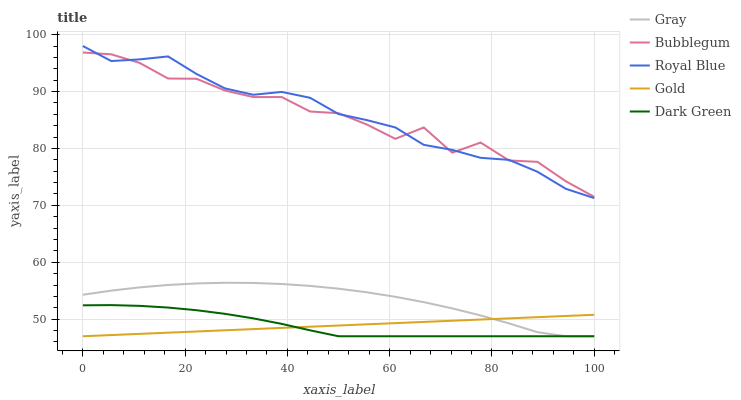Does Dark Green have the minimum area under the curve?
Answer yes or no. Yes. Does Royal Blue have the maximum area under the curve?
Answer yes or no. Yes. Does Gold have the minimum area under the curve?
Answer yes or no. No. Does Gold have the maximum area under the curve?
Answer yes or no. No. Is Gold the smoothest?
Answer yes or no. Yes. Is Bubblegum the roughest?
Answer yes or no. Yes. Is Dark Green the smoothest?
Answer yes or no. No. Is Dark Green the roughest?
Answer yes or no. No. Does Gray have the lowest value?
Answer yes or no. Yes. Does Bubblegum have the lowest value?
Answer yes or no. No. Does Royal Blue have the highest value?
Answer yes or no. Yes. Does Dark Green have the highest value?
Answer yes or no. No. Is Gold less than Bubblegum?
Answer yes or no. Yes. Is Bubblegum greater than Dark Green?
Answer yes or no. Yes. Does Dark Green intersect Gold?
Answer yes or no. Yes. Is Dark Green less than Gold?
Answer yes or no. No. Is Dark Green greater than Gold?
Answer yes or no. No. Does Gold intersect Bubblegum?
Answer yes or no. No. 